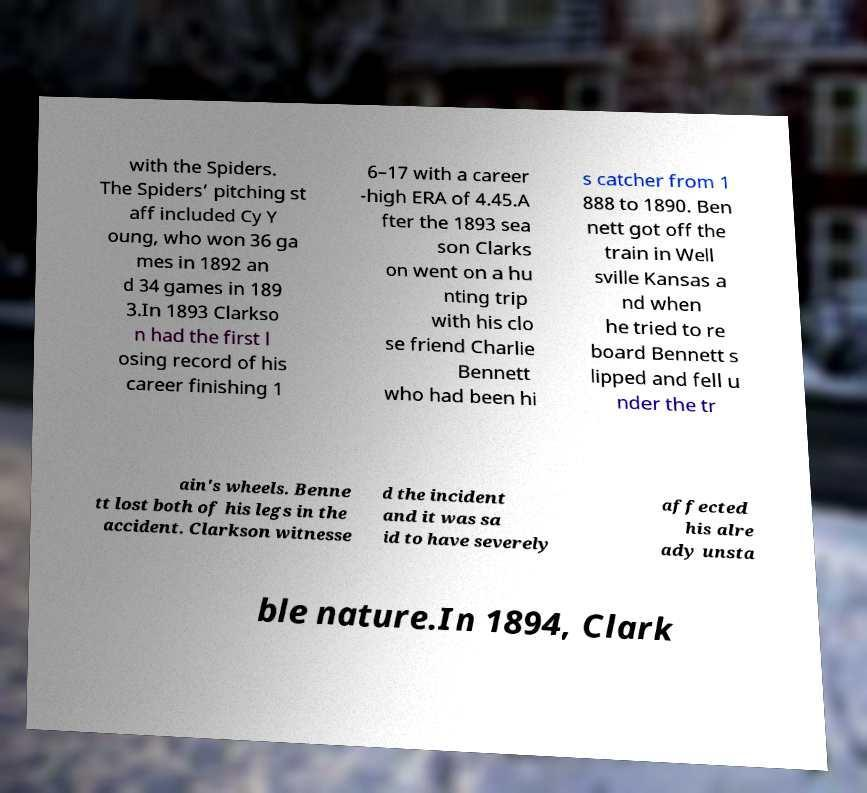Could you extract and type out the text from this image? with the Spiders. The Spiders’ pitching st aff included Cy Y oung, who won 36 ga mes in 1892 an d 34 games in 189 3.In 1893 Clarkso n had the first l osing record of his career finishing 1 6–17 with a career -high ERA of 4.45.A fter the 1893 sea son Clarks on went on a hu nting trip with his clo se friend Charlie Bennett who had been hi s catcher from 1 888 to 1890. Ben nett got off the train in Well sville Kansas a nd when he tried to re board Bennett s lipped and fell u nder the tr ain's wheels. Benne tt lost both of his legs in the accident. Clarkson witnesse d the incident and it was sa id to have severely affected his alre ady unsta ble nature.In 1894, Clark 